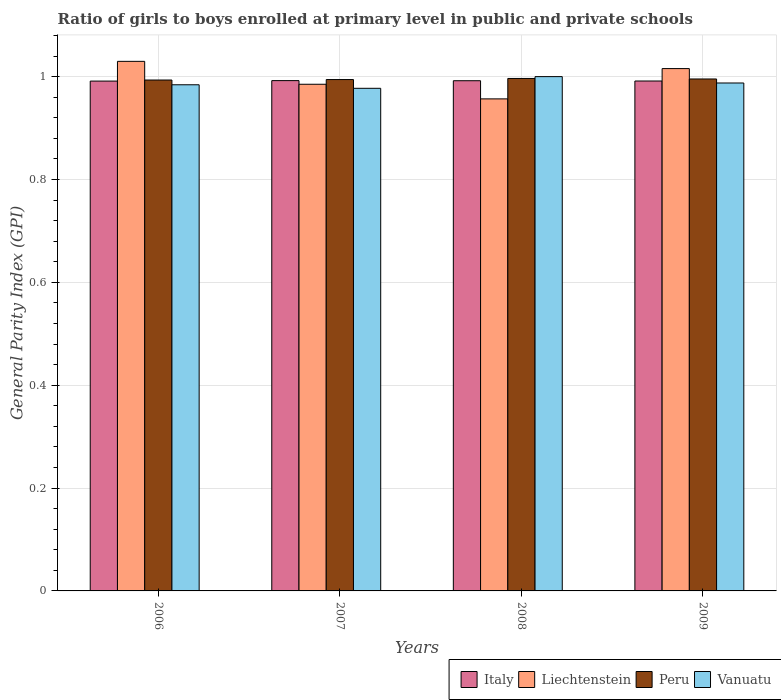How many different coloured bars are there?
Ensure brevity in your answer.  4. How many groups of bars are there?
Offer a very short reply. 4. How many bars are there on the 2nd tick from the right?
Ensure brevity in your answer.  4. In how many cases, is the number of bars for a given year not equal to the number of legend labels?
Keep it short and to the point. 0. What is the general parity index in Italy in 2009?
Provide a short and direct response. 0.99. Across all years, what is the maximum general parity index in Peru?
Keep it short and to the point. 1. Across all years, what is the minimum general parity index in Italy?
Provide a succinct answer. 0.99. In which year was the general parity index in Liechtenstein minimum?
Give a very brief answer. 2008. What is the total general parity index in Vanuatu in the graph?
Provide a succinct answer. 3.95. What is the difference between the general parity index in Liechtenstein in 2006 and that in 2007?
Offer a very short reply. 0.04. What is the difference between the general parity index in Vanuatu in 2007 and the general parity index in Peru in 2009?
Your answer should be very brief. -0.02. What is the average general parity index in Italy per year?
Provide a succinct answer. 0.99. In the year 2007, what is the difference between the general parity index in Liechtenstein and general parity index in Peru?
Provide a succinct answer. -0.01. What is the ratio of the general parity index in Italy in 2007 to that in 2009?
Ensure brevity in your answer.  1. What is the difference between the highest and the second highest general parity index in Liechtenstein?
Provide a short and direct response. 0.01. What is the difference between the highest and the lowest general parity index in Vanuatu?
Provide a succinct answer. 0.02. In how many years, is the general parity index in Italy greater than the average general parity index in Italy taken over all years?
Provide a short and direct response. 2. Is the sum of the general parity index in Italy in 2006 and 2009 greater than the maximum general parity index in Vanuatu across all years?
Your answer should be very brief. Yes. Is it the case that in every year, the sum of the general parity index in Vanuatu and general parity index in Italy is greater than the sum of general parity index in Peru and general parity index in Liechtenstein?
Provide a short and direct response. No. How many bars are there?
Provide a short and direct response. 16. How many years are there in the graph?
Make the answer very short. 4. Does the graph contain any zero values?
Keep it short and to the point. No. How many legend labels are there?
Provide a short and direct response. 4. How are the legend labels stacked?
Your answer should be compact. Horizontal. What is the title of the graph?
Provide a succinct answer. Ratio of girls to boys enrolled at primary level in public and private schools. What is the label or title of the X-axis?
Keep it short and to the point. Years. What is the label or title of the Y-axis?
Keep it short and to the point. General Parity Index (GPI). What is the General Parity Index (GPI) in Italy in 2006?
Your response must be concise. 0.99. What is the General Parity Index (GPI) in Liechtenstein in 2006?
Give a very brief answer. 1.03. What is the General Parity Index (GPI) of Peru in 2006?
Give a very brief answer. 0.99. What is the General Parity Index (GPI) in Vanuatu in 2006?
Ensure brevity in your answer.  0.98. What is the General Parity Index (GPI) in Italy in 2007?
Ensure brevity in your answer.  0.99. What is the General Parity Index (GPI) of Liechtenstein in 2007?
Make the answer very short. 0.99. What is the General Parity Index (GPI) in Peru in 2007?
Provide a short and direct response. 0.99. What is the General Parity Index (GPI) of Vanuatu in 2007?
Give a very brief answer. 0.98. What is the General Parity Index (GPI) in Italy in 2008?
Keep it short and to the point. 0.99. What is the General Parity Index (GPI) of Liechtenstein in 2008?
Make the answer very short. 0.96. What is the General Parity Index (GPI) in Peru in 2008?
Your response must be concise. 1. What is the General Parity Index (GPI) in Vanuatu in 2008?
Provide a short and direct response. 1. What is the General Parity Index (GPI) of Italy in 2009?
Your answer should be very brief. 0.99. What is the General Parity Index (GPI) in Liechtenstein in 2009?
Your answer should be very brief. 1.02. What is the General Parity Index (GPI) of Peru in 2009?
Provide a short and direct response. 1. What is the General Parity Index (GPI) in Vanuatu in 2009?
Offer a very short reply. 0.99. Across all years, what is the maximum General Parity Index (GPI) of Italy?
Offer a very short reply. 0.99. Across all years, what is the maximum General Parity Index (GPI) in Liechtenstein?
Offer a very short reply. 1.03. Across all years, what is the maximum General Parity Index (GPI) of Peru?
Your answer should be compact. 1. Across all years, what is the maximum General Parity Index (GPI) of Vanuatu?
Offer a terse response. 1. Across all years, what is the minimum General Parity Index (GPI) of Italy?
Your response must be concise. 0.99. Across all years, what is the minimum General Parity Index (GPI) in Liechtenstein?
Your response must be concise. 0.96. Across all years, what is the minimum General Parity Index (GPI) of Peru?
Ensure brevity in your answer.  0.99. Across all years, what is the minimum General Parity Index (GPI) in Vanuatu?
Ensure brevity in your answer.  0.98. What is the total General Parity Index (GPI) in Italy in the graph?
Provide a succinct answer. 3.97. What is the total General Parity Index (GPI) in Liechtenstein in the graph?
Make the answer very short. 3.99. What is the total General Parity Index (GPI) of Peru in the graph?
Your response must be concise. 3.98. What is the total General Parity Index (GPI) in Vanuatu in the graph?
Provide a short and direct response. 3.95. What is the difference between the General Parity Index (GPI) in Italy in 2006 and that in 2007?
Ensure brevity in your answer.  -0. What is the difference between the General Parity Index (GPI) of Liechtenstein in 2006 and that in 2007?
Offer a terse response. 0.04. What is the difference between the General Parity Index (GPI) in Peru in 2006 and that in 2007?
Keep it short and to the point. -0. What is the difference between the General Parity Index (GPI) of Vanuatu in 2006 and that in 2007?
Your response must be concise. 0.01. What is the difference between the General Parity Index (GPI) of Italy in 2006 and that in 2008?
Keep it short and to the point. -0. What is the difference between the General Parity Index (GPI) of Liechtenstein in 2006 and that in 2008?
Your answer should be very brief. 0.07. What is the difference between the General Parity Index (GPI) in Peru in 2006 and that in 2008?
Make the answer very short. -0. What is the difference between the General Parity Index (GPI) in Vanuatu in 2006 and that in 2008?
Your answer should be very brief. -0.02. What is the difference between the General Parity Index (GPI) of Italy in 2006 and that in 2009?
Provide a short and direct response. -0. What is the difference between the General Parity Index (GPI) of Liechtenstein in 2006 and that in 2009?
Make the answer very short. 0.01. What is the difference between the General Parity Index (GPI) in Peru in 2006 and that in 2009?
Offer a terse response. -0. What is the difference between the General Parity Index (GPI) in Vanuatu in 2006 and that in 2009?
Your answer should be compact. -0. What is the difference between the General Parity Index (GPI) in Italy in 2007 and that in 2008?
Provide a succinct answer. 0. What is the difference between the General Parity Index (GPI) in Liechtenstein in 2007 and that in 2008?
Make the answer very short. 0.03. What is the difference between the General Parity Index (GPI) in Peru in 2007 and that in 2008?
Offer a terse response. -0. What is the difference between the General Parity Index (GPI) in Vanuatu in 2007 and that in 2008?
Keep it short and to the point. -0.02. What is the difference between the General Parity Index (GPI) in Italy in 2007 and that in 2009?
Provide a succinct answer. 0. What is the difference between the General Parity Index (GPI) of Liechtenstein in 2007 and that in 2009?
Provide a succinct answer. -0.03. What is the difference between the General Parity Index (GPI) in Peru in 2007 and that in 2009?
Provide a succinct answer. -0. What is the difference between the General Parity Index (GPI) in Vanuatu in 2007 and that in 2009?
Keep it short and to the point. -0.01. What is the difference between the General Parity Index (GPI) of Italy in 2008 and that in 2009?
Your answer should be very brief. 0. What is the difference between the General Parity Index (GPI) of Liechtenstein in 2008 and that in 2009?
Your response must be concise. -0.06. What is the difference between the General Parity Index (GPI) in Vanuatu in 2008 and that in 2009?
Your answer should be very brief. 0.01. What is the difference between the General Parity Index (GPI) in Italy in 2006 and the General Parity Index (GPI) in Liechtenstein in 2007?
Your answer should be very brief. 0.01. What is the difference between the General Parity Index (GPI) in Italy in 2006 and the General Parity Index (GPI) in Peru in 2007?
Your answer should be very brief. -0. What is the difference between the General Parity Index (GPI) of Italy in 2006 and the General Parity Index (GPI) of Vanuatu in 2007?
Your answer should be very brief. 0.01. What is the difference between the General Parity Index (GPI) of Liechtenstein in 2006 and the General Parity Index (GPI) of Peru in 2007?
Your answer should be very brief. 0.04. What is the difference between the General Parity Index (GPI) of Liechtenstein in 2006 and the General Parity Index (GPI) of Vanuatu in 2007?
Offer a terse response. 0.05. What is the difference between the General Parity Index (GPI) in Peru in 2006 and the General Parity Index (GPI) in Vanuatu in 2007?
Provide a succinct answer. 0.02. What is the difference between the General Parity Index (GPI) in Italy in 2006 and the General Parity Index (GPI) in Liechtenstein in 2008?
Your answer should be very brief. 0.03. What is the difference between the General Parity Index (GPI) of Italy in 2006 and the General Parity Index (GPI) of Peru in 2008?
Give a very brief answer. -0.01. What is the difference between the General Parity Index (GPI) in Italy in 2006 and the General Parity Index (GPI) in Vanuatu in 2008?
Your answer should be very brief. -0.01. What is the difference between the General Parity Index (GPI) of Liechtenstein in 2006 and the General Parity Index (GPI) of Vanuatu in 2008?
Ensure brevity in your answer.  0.03. What is the difference between the General Parity Index (GPI) in Peru in 2006 and the General Parity Index (GPI) in Vanuatu in 2008?
Provide a succinct answer. -0.01. What is the difference between the General Parity Index (GPI) in Italy in 2006 and the General Parity Index (GPI) in Liechtenstein in 2009?
Offer a terse response. -0.02. What is the difference between the General Parity Index (GPI) of Italy in 2006 and the General Parity Index (GPI) of Peru in 2009?
Your answer should be very brief. -0. What is the difference between the General Parity Index (GPI) of Italy in 2006 and the General Parity Index (GPI) of Vanuatu in 2009?
Ensure brevity in your answer.  0. What is the difference between the General Parity Index (GPI) in Liechtenstein in 2006 and the General Parity Index (GPI) in Peru in 2009?
Your answer should be compact. 0.03. What is the difference between the General Parity Index (GPI) in Liechtenstein in 2006 and the General Parity Index (GPI) in Vanuatu in 2009?
Your answer should be compact. 0.04. What is the difference between the General Parity Index (GPI) in Peru in 2006 and the General Parity Index (GPI) in Vanuatu in 2009?
Offer a very short reply. 0.01. What is the difference between the General Parity Index (GPI) in Italy in 2007 and the General Parity Index (GPI) in Liechtenstein in 2008?
Provide a succinct answer. 0.04. What is the difference between the General Parity Index (GPI) of Italy in 2007 and the General Parity Index (GPI) of Peru in 2008?
Offer a very short reply. -0. What is the difference between the General Parity Index (GPI) of Italy in 2007 and the General Parity Index (GPI) of Vanuatu in 2008?
Provide a succinct answer. -0.01. What is the difference between the General Parity Index (GPI) in Liechtenstein in 2007 and the General Parity Index (GPI) in Peru in 2008?
Provide a short and direct response. -0.01. What is the difference between the General Parity Index (GPI) of Liechtenstein in 2007 and the General Parity Index (GPI) of Vanuatu in 2008?
Your response must be concise. -0.01. What is the difference between the General Parity Index (GPI) of Peru in 2007 and the General Parity Index (GPI) of Vanuatu in 2008?
Provide a succinct answer. -0.01. What is the difference between the General Parity Index (GPI) of Italy in 2007 and the General Parity Index (GPI) of Liechtenstein in 2009?
Give a very brief answer. -0.02. What is the difference between the General Parity Index (GPI) of Italy in 2007 and the General Parity Index (GPI) of Peru in 2009?
Provide a short and direct response. -0. What is the difference between the General Parity Index (GPI) in Italy in 2007 and the General Parity Index (GPI) in Vanuatu in 2009?
Your response must be concise. 0. What is the difference between the General Parity Index (GPI) in Liechtenstein in 2007 and the General Parity Index (GPI) in Peru in 2009?
Offer a very short reply. -0.01. What is the difference between the General Parity Index (GPI) of Liechtenstein in 2007 and the General Parity Index (GPI) of Vanuatu in 2009?
Provide a short and direct response. -0. What is the difference between the General Parity Index (GPI) of Peru in 2007 and the General Parity Index (GPI) of Vanuatu in 2009?
Your answer should be very brief. 0.01. What is the difference between the General Parity Index (GPI) in Italy in 2008 and the General Parity Index (GPI) in Liechtenstein in 2009?
Offer a terse response. -0.02. What is the difference between the General Parity Index (GPI) in Italy in 2008 and the General Parity Index (GPI) in Peru in 2009?
Offer a terse response. -0. What is the difference between the General Parity Index (GPI) in Italy in 2008 and the General Parity Index (GPI) in Vanuatu in 2009?
Your response must be concise. 0. What is the difference between the General Parity Index (GPI) in Liechtenstein in 2008 and the General Parity Index (GPI) in Peru in 2009?
Give a very brief answer. -0.04. What is the difference between the General Parity Index (GPI) of Liechtenstein in 2008 and the General Parity Index (GPI) of Vanuatu in 2009?
Ensure brevity in your answer.  -0.03. What is the difference between the General Parity Index (GPI) in Peru in 2008 and the General Parity Index (GPI) in Vanuatu in 2009?
Provide a short and direct response. 0.01. What is the average General Parity Index (GPI) of Vanuatu per year?
Offer a terse response. 0.99. In the year 2006, what is the difference between the General Parity Index (GPI) in Italy and General Parity Index (GPI) in Liechtenstein?
Your answer should be compact. -0.04. In the year 2006, what is the difference between the General Parity Index (GPI) of Italy and General Parity Index (GPI) of Peru?
Keep it short and to the point. -0. In the year 2006, what is the difference between the General Parity Index (GPI) in Italy and General Parity Index (GPI) in Vanuatu?
Your response must be concise. 0.01. In the year 2006, what is the difference between the General Parity Index (GPI) of Liechtenstein and General Parity Index (GPI) of Peru?
Provide a succinct answer. 0.04. In the year 2006, what is the difference between the General Parity Index (GPI) in Liechtenstein and General Parity Index (GPI) in Vanuatu?
Provide a succinct answer. 0.05. In the year 2006, what is the difference between the General Parity Index (GPI) of Peru and General Parity Index (GPI) of Vanuatu?
Give a very brief answer. 0.01. In the year 2007, what is the difference between the General Parity Index (GPI) in Italy and General Parity Index (GPI) in Liechtenstein?
Your answer should be very brief. 0.01. In the year 2007, what is the difference between the General Parity Index (GPI) in Italy and General Parity Index (GPI) in Peru?
Provide a short and direct response. -0. In the year 2007, what is the difference between the General Parity Index (GPI) of Italy and General Parity Index (GPI) of Vanuatu?
Keep it short and to the point. 0.01. In the year 2007, what is the difference between the General Parity Index (GPI) of Liechtenstein and General Parity Index (GPI) of Peru?
Give a very brief answer. -0.01. In the year 2007, what is the difference between the General Parity Index (GPI) of Liechtenstein and General Parity Index (GPI) of Vanuatu?
Your answer should be very brief. 0.01. In the year 2007, what is the difference between the General Parity Index (GPI) of Peru and General Parity Index (GPI) of Vanuatu?
Your answer should be very brief. 0.02. In the year 2008, what is the difference between the General Parity Index (GPI) in Italy and General Parity Index (GPI) in Liechtenstein?
Keep it short and to the point. 0.04. In the year 2008, what is the difference between the General Parity Index (GPI) of Italy and General Parity Index (GPI) of Peru?
Your answer should be very brief. -0. In the year 2008, what is the difference between the General Parity Index (GPI) of Italy and General Parity Index (GPI) of Vanuatu?
Provide a short and direct response. -0.01. In the year 2008, what is the difference between the General Parity Index (GPI) of Liechtenstein and General Parity Index (GPI) of Peru?
Offer a terse response. -0.04. In the year 2008, what is the difference between the General Parity Index (GPI) of Liechtenstein and General Parity Index (GPI) of Vanuatu?
Provide a succinct answer. -0.04. In the year 2008, what is the difference between the General Parity Index (GPI) of Peru and General Parity Index (GPI) of Vanuatu?
Give a very brief answer. -0. In the year 2009, what is the difference between the General Parity Index (GPI) of Italy and General Parity Index (GPI) of Liechtenstein?
Your response must be concise. -0.02. In the year 2009, what is the difference between the General Parity Index (GPI) in Italy and General Parity Index (GPI) in Peru?
Give a very brief answer. -0. In the year 2009, what is the difference between the General Parity Index (GPI) in Italy and General Parity Index (GPI) in Vanuatu?
Make the answer very short. 0. In the year 2009, what is the difference between the General Parity Index (GPI) in Liechtenstein and General Parity Index (GPI) in Peru?
Provide a short and direct response. 0.02. In the year 2009, what is the difference between the General Parity Index (GPI) of Liechtenstein and General Parity Index (GPI) of Vanuatu?
Your answer should be compact. 0.03. In the year 2009, what is the difference between the General Parity Index (GPI) in Peru and General Parity Index (GPI) in Vanuatu?
Give a very brief answer. 0.01. What is the ratio of the General Parity Index (GPI) in Italy in 2006 to that in 2007?
Provide a short and direct response. 1. What is the ratio of the General Parity Index (GPI) of Liechtenstein in 2006 to that in 2007?
Keep it short and to the point. 1.05. What is the ratio of the General Parity Index (GPI) in Peru in 2006 to that in 2007?
Offer a very short reply. 1. What is the ratio of the General Parity Index (GPI) of Liechtenstein in 2006 to that in 2008?
Make the answer very short. 1.08. What is the ratio of the General Parity Index (GPI) of Vanuatu in 2006 to that in 2008?
Provide a short and direct response. 0.98. What is the ratio of the General Parity Index (GPI) of Italy in 2006 to that in 2009?
Keep it short and to the point. 1. What is the ratio of the General Parity Index (GPI) in Liechtenstein in 2006 to that in 2009?
Provide a short and direct response. 1.01. What is the ratio of the General Parity Index (GPI) of Peru in 2006 to that in 2009?
Your answer should be very brief. 1. What is the ratio of the General Parity Index (GPI) in Vanuatu in 2006 to that in 2009?
Your answer should be compact. 1. What is the ratio of the General Parity Index (GPI) of Liechtenstein in 2007 to that in 2008?
Provide a succinct answer. 1.03. What is the ratio of the General Parity Index (GPI) in Vanuatu in 2007 to that in 2008?
Ensure brevity in your answer.  0.98. What is the ratio of the General Parity Index (GPI) of Peru in 2007 to that in 2009?
Keep it short and to the point. 1. What is the ratio of the General Parity Index (GPI) of Italy in 2008 to that in 2009?
Give a very brief answer. 1. What is the ratio of the General Parity Index (GPI) in Liechtenstein in 2008 to that in 2009?
Make the answer very short. 0.94. What is the ratio of the General Parity Index (GPI) of Vanuatu in 2008 to that in 2009?
Offer a terse response. 1.01. What is the difference between the highest and the second highest General Parity Index (GPI) of Liechtenstein?
Ensure brevity in your answer.  0.01. What is the difference between the highest and the second highest General Parity Index (GPI) of Peru?
Give a very brief answer. 0. What is the difference between the highest and the second highest General Parity Index (GPI) in Vanuatu?
Your response must be concise. 0.01. What is the difference between the highest and the lowest General Parity Index (GPI) of Italy?
Provide a short and direct response. 0. What is the difference between the highest and the lowest General Parity Index (GPI) in Liechtenstein?
Give a very brief answer. 0.07. What is the difference between the highest and the lowest General Parity Index (GPI) of Peru?
Make the answer very short. 0. What is the difference between the highest and the lowest General Parity Index (GPI) in Vanuatu?
Provide a succinct answer. 0.02. 